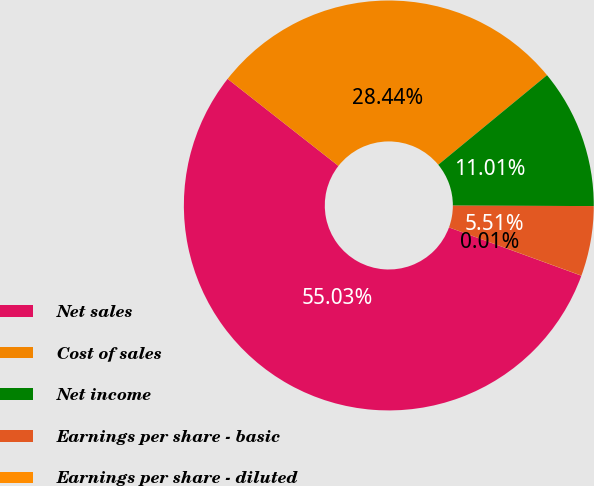Convert chart. <chart><loc_0><loc_0><loc_500><loc_500><pie_chart><fcel>Net sales<fcel>Cost of sales<fcel>Net income<fcel>Earnings per share - basic<fcel>Earnings per share - diluted<nl><fcel>55.02%<fcel>28.44%<fcel>11.01%<fcel>5.51%<fcel>0.01%<nl></chart> 